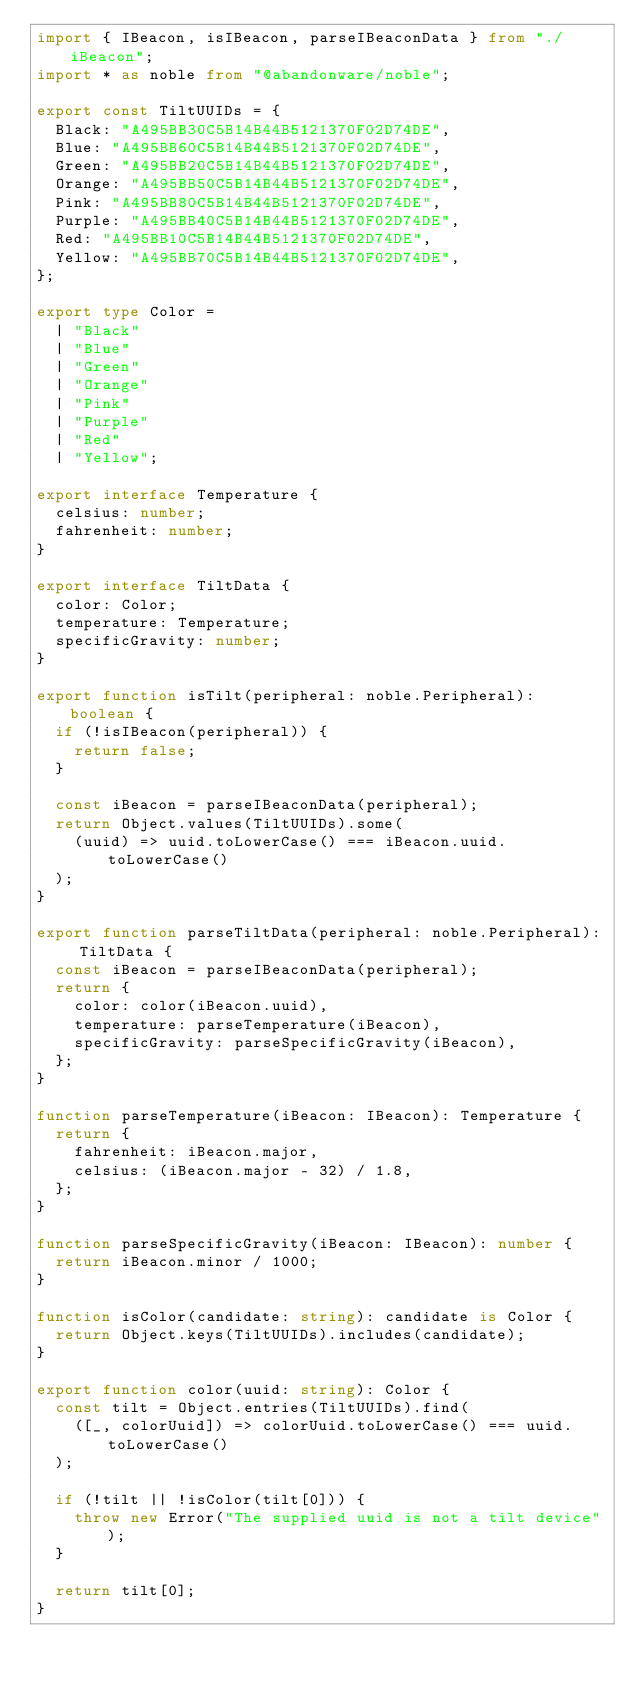<code> <loc_0><loc_0><loc_500><loc_500><_TypeScript_>import { IBeacon, isIBeacon, parseIBeaconData } from "./iBeacon";
import * as noble from "@abandonware/noble";

export const TiltUUIDs = {
  Black: "A495BB30C5B14B44B5121370F02D74DE",
  Blue: "A495BB60C5B14B44B5121370F02D74DE",
  Green: "A495BB20C5B14B44B5121370F02D74DE",
  Orange: "A495BB50C5B14B44B5121370F02D74DE",
  Pink: "A495BB80C5B14B44B5121370F02D74DE",
  Purple: "A495BB40C5B14B44B5121370F02D74DE",
  Red: "A495BB10C5B14B44B5121370F02D74DE",
  Yellow: "A495BB70C5B14B44B5121370F02D74DE",
};

export type Color =
  | "Black"
  | "Blue"
  | "Green"
  | "Orange"
  | "Pink"
  | "Purple"
  | "Red"
  | "Yellow";

export interface Temperature {
  celsius: number;
  fahrenheit: number;
}

export interface TiltData {
  color: Color;
  temperature: Temperature;
  specificGravity: number;
}

export function isTilt(peripheral: noble.Peripheral): boolean {
  if (!isIBeacon(peripheral)) {
    return false;
  }

  const iBeacon = parseIBeaconData(peripheral);
  return Object.values(TiltUUIDs).some(
    (uuid) => uuid.toLowerCase() === iBeacon.uuid.toLowerCase()
  );
}

export function parseTiltData(peripheral: noble.Peripheral): TiltData {
  const iBeacon = parseIBeaconData(peripheral);
  return {
    color: color(iBeacon.uuid),
    temperature: parseTemperature(iBeacon),
    specificGravity: parseSpecificGravity(iBeacon),
  };
}

function parseTemperature(iBeacon: IBeacon): Temperature {
  return {
    fahrenheit: iBeacon.major,
    celsius: (iBeacon.major - 32) / 1.8,
  };
}

function parseSpecificGravity(iBeacon: IBeacon): number {
  return iBeacon.minor / 1000;
}

function isColor(candidate: string): candidate is Color {
  return Object.keys(TiltUUIDs).includes(candidate);
}

export function color(uuid: string): Color {
  const tilt = Object.entries(TiltUUIDs).find(
    ([_, colorUuid]) => colorUuid.toLowerCase() === uuid.toLowerCase()
  );

  if (!tilt || !isColor(tilt[0])) {
    throw new Error("The supplied uuid is not a tilt device");
  }

  return tilt[0];
}
</code> 